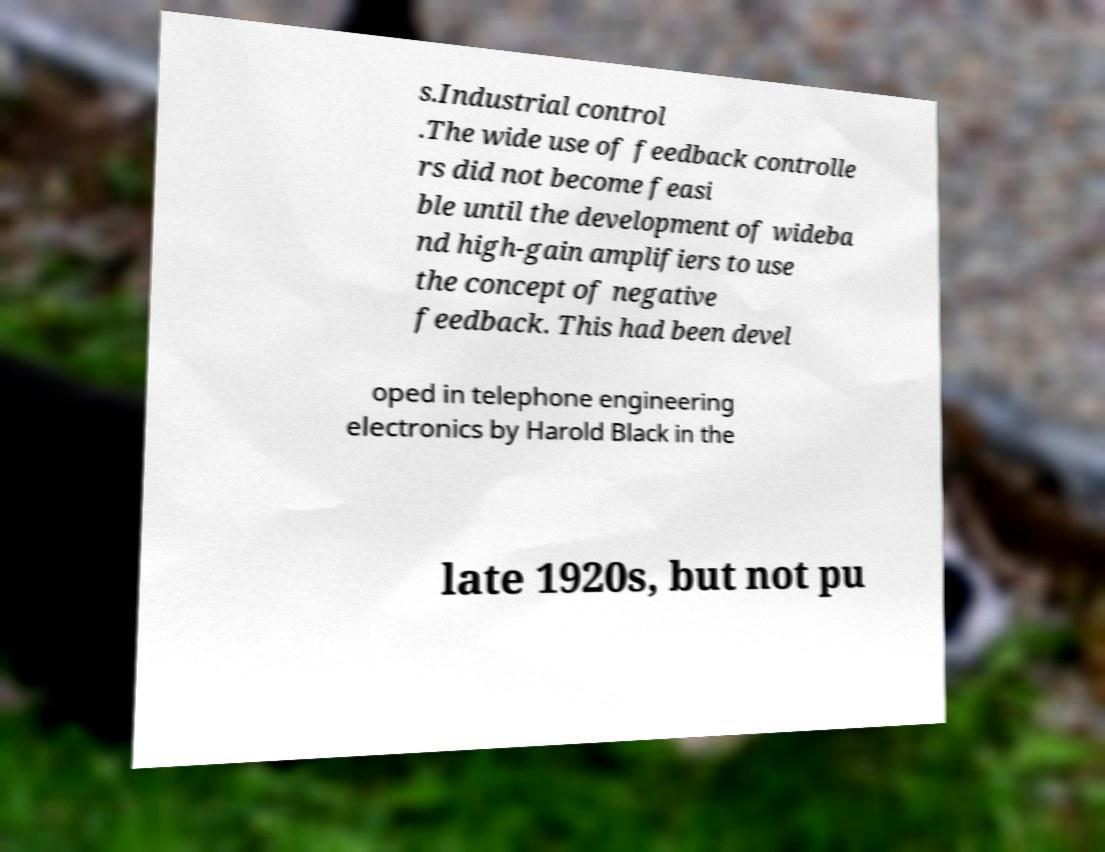Can you accurately transcribe the text from the provided image for me? s.Industrial control .The wide use of feedback controlle rs did not become feasi ble until the development of wideba nd high-gain amplifiers to use the concept of negative feedback. This had been devel oped in telephone engineering electronics by Harold Black in the late 1920s, but not pu 